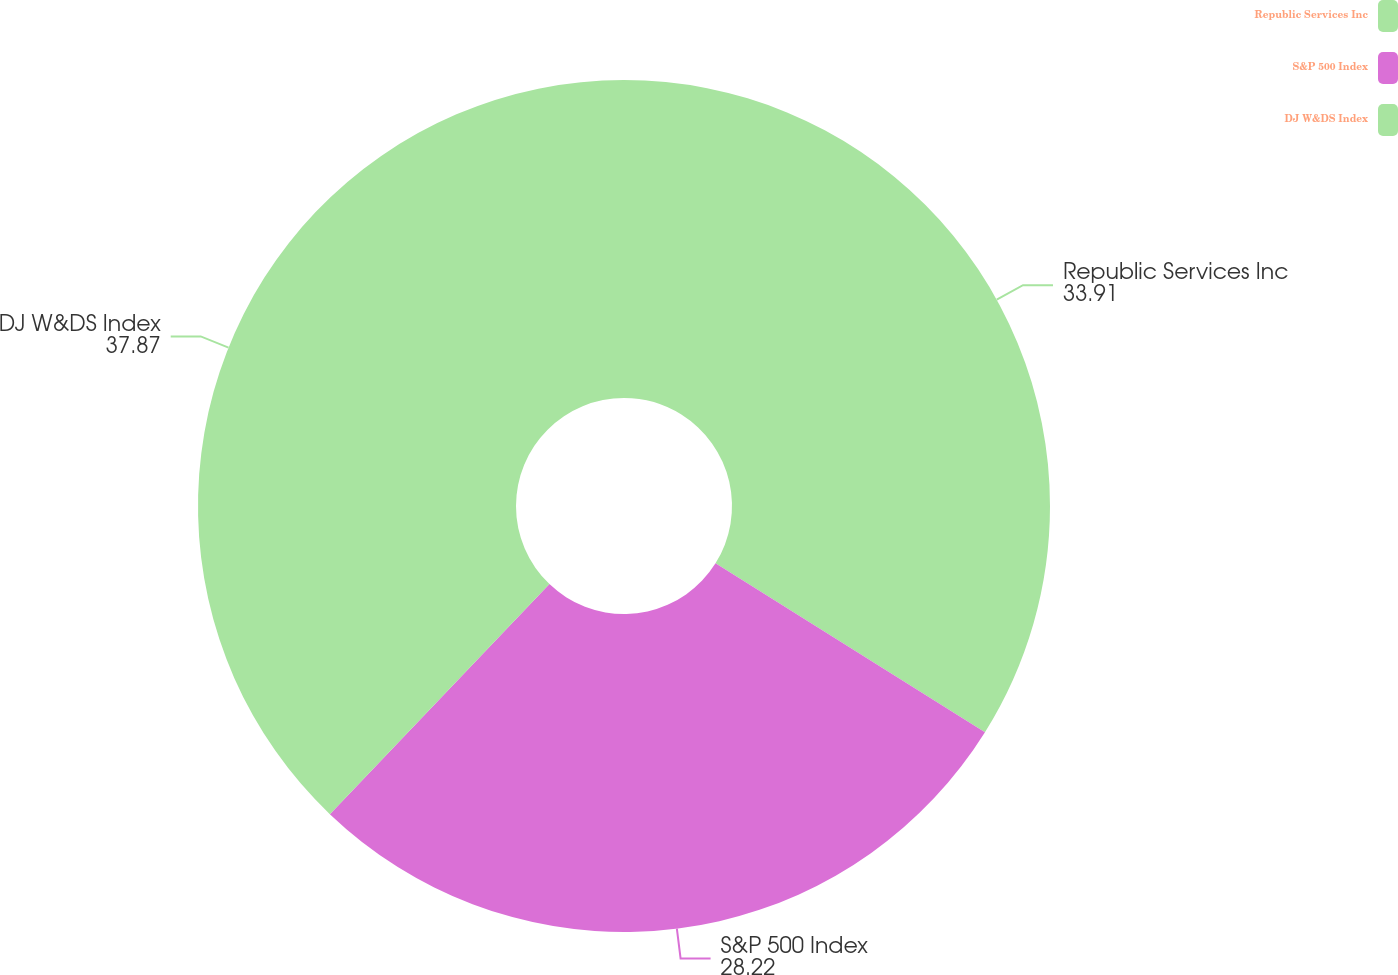Convert chart. <chart><loc_0><loc_0><loc_500><loc_500><pie_chart><fcel>Republic Services Inc<fcel>S&P 500 Index<fcel>DJ W&DS Index<nl><fcel>33.91%<fcel>28.22%<fcel>37.87%<nl></chart> 